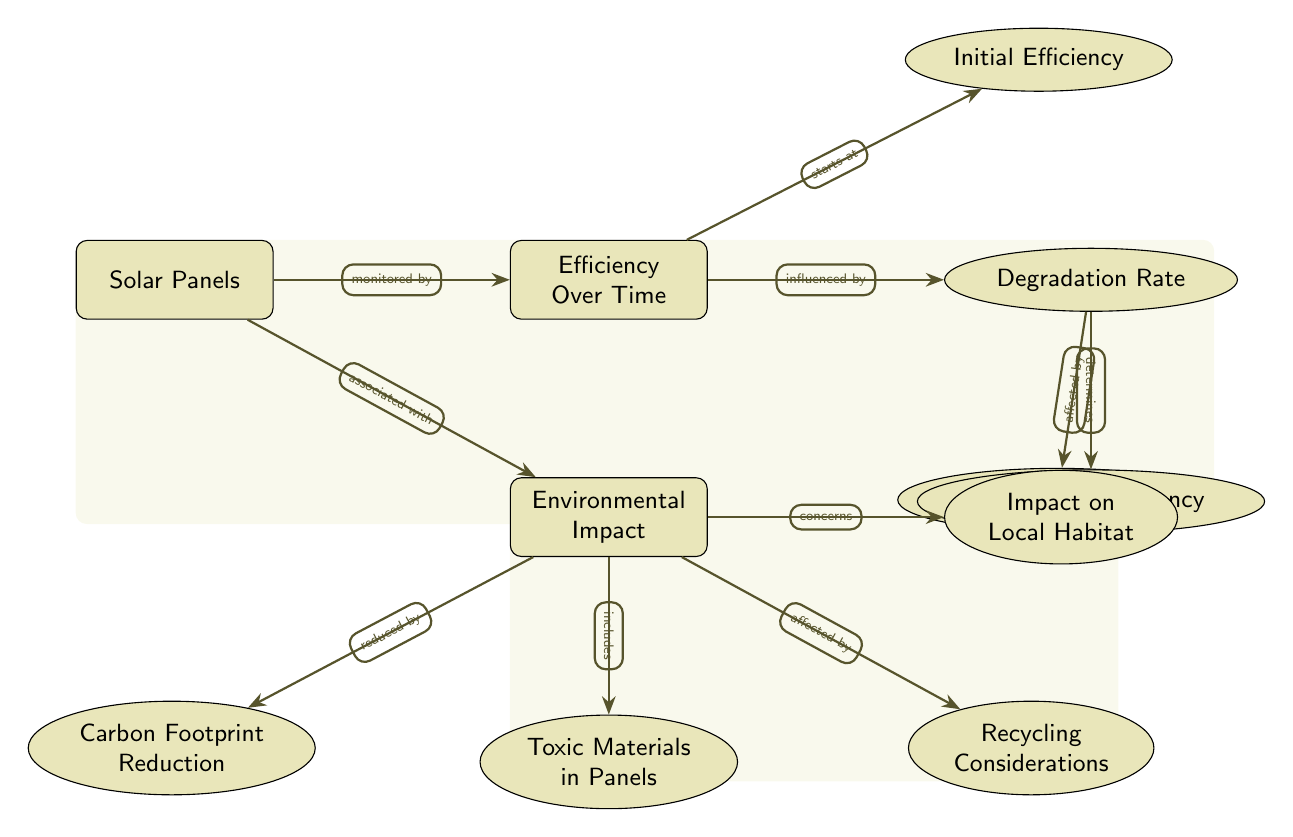What is the main node that represents solar energy technology? The main node labeled "Solar Panels" represents the technology associated with solar energy.
Answer: Solar Panels How many subnodes are associated with the "Efficiency Over Time"? There are four subnodes branching off from "Efficiency Over Time," which detail various aspects influencing solar panel efficiency.
Answer: 4 What influences the "Degradation Rate"? The "Degradation Rate" is influenced by the "Temperature Effect," indicating that temperature can impact how solar panel efficiency declines over time.
Answer: Temperature Effect Which environmental aspect is concerned with pollutants in solar panel production? The subnode labeled "Toxic Materials in Panels" addresses concerns regarding the hazardous substances utilized in making solar panels.
Answer: Toxic Materials in Panels Which aspect associated with environmental impact is directly linked to reducing carbon emissions? The subnode "Carbon Footprint Reduction" is tied to the environmental benefit of solar panels in decreasing carbon emissions.
Answer: Carbon Footprint Reduction How does "Degradation Rate" affect "Long-Term Efficiency"? The "Degradation Rate" determines the "Long-Term Efficiency," meaning that the rate at which solar panel efficiency declines will influence how efficient they remain over an extended period.
Answer: Determines What node shows the impact of solar panels on local ecosystems? The subnode "Impact on Local Habitat" reflects the potential consequences that solar energy installations may have on local wildlife and ecosystems.
Answer: Impact on Local Habitat What type of relationship exists between "Solar Panels" and "Environmental Impact"? The diagram indicates that "Solar Panels" are associated with "Environmental Impact," suggesting that the deployment of solar panels directly relates to environmental considerations.
Answer: Associated with Which subnode under "Environmental Impact" discusses reusing materials from old panels? The subnode "Recycling Considerations" refers to the implications and processes involved in reusing materials from solar panels at the end of their life cycle.
Answer: Recycling Considerations 